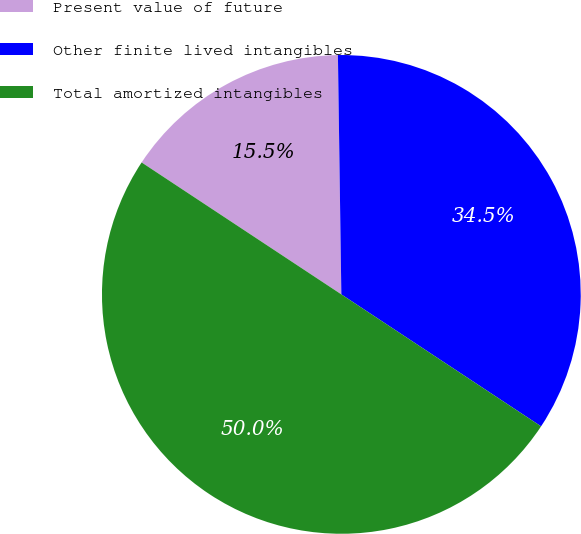<chart> <loc_0><loc_0><loc_500><loc_500><pie_chart><fcel>Present value of future<fcel>Other finite lived intangibles<fcel>Total amortized intangibles<nl><fcel>15.48%<fcel>34.52%<fcel>50.0%<nl></chart> 